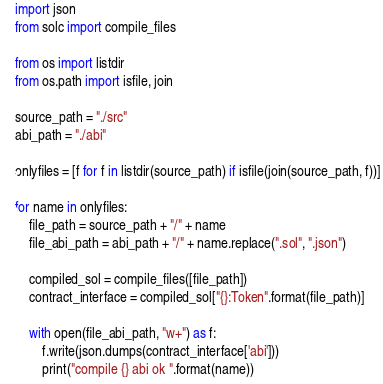<code> <loc_0><loc_0><loc_500><loc_500><_Python_>import json
from solc import compile_files

from os import listdir
from os.path import isfile, join

source_path = "./src"
abi_path = "./abi"

onlyfiles = [f for f in listdir(source_path) if isfile(join(source_path, f))]

for name in onlyfiles:
    file_path = source_path + "/" + name
    file_abi_path = abi_path + "/" + name.replace(".sol", ".json")

    compiled_sol = compile_files([file_path])
    contract_interface = compiled_sol["{}:Token".format(file_path)]

    with open(file_abi_path, "w+") as f:
        f.write(json.dumps(contract_interface['abi']))
        print("compile {} abi ok ".format(name))
</code> 